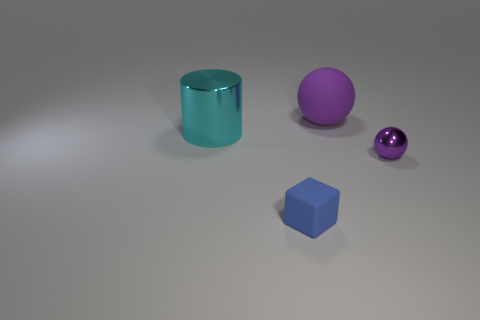Is the color of the shiny object to the right of the large shiny object the same as the rubber ball?
Your answer should be very brief. Yes. What number of purple things are metal balls or large spheres?
Offer a terse response. 2. There is a ball on the right side of the rubber object that is right of the tiny blue block; what color is it?
Your answer should be very brief. Purple. There is a large sphere that is the same color as the tiny metal ball; what material is it?
Make the answer very short. Rubber. What is the color of the metal thing that is in front of the large metallic cylinder?
Provide a short and direct response. Purple. There is a matte thing that is behind the cyan cylinder; is it the same size as the big shiny thing?
Ensure brevity in your answer.  Yes. The shiny object that is the same color as the matte sphere is what size?
Keep it short and to the point. Small. Is there another cube of the same size as the blue rubber block?
Your answer should be very brief. No. Do the shiny object that is in front of the large cylinder and the small object that is on the left side of the metal sphere have the same color?
Give a very brief answer. No. Are there any tiny matte things that have the same color as the tiny rubber block?
Give a very brief answer. No. 